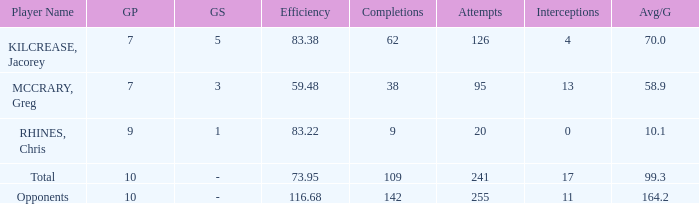What is the lowest effic with a 58.9 avg/g? 59.48. 